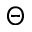<formula> <loc_0><loc_0><loc_500><loc_500>\Theta</formula> 